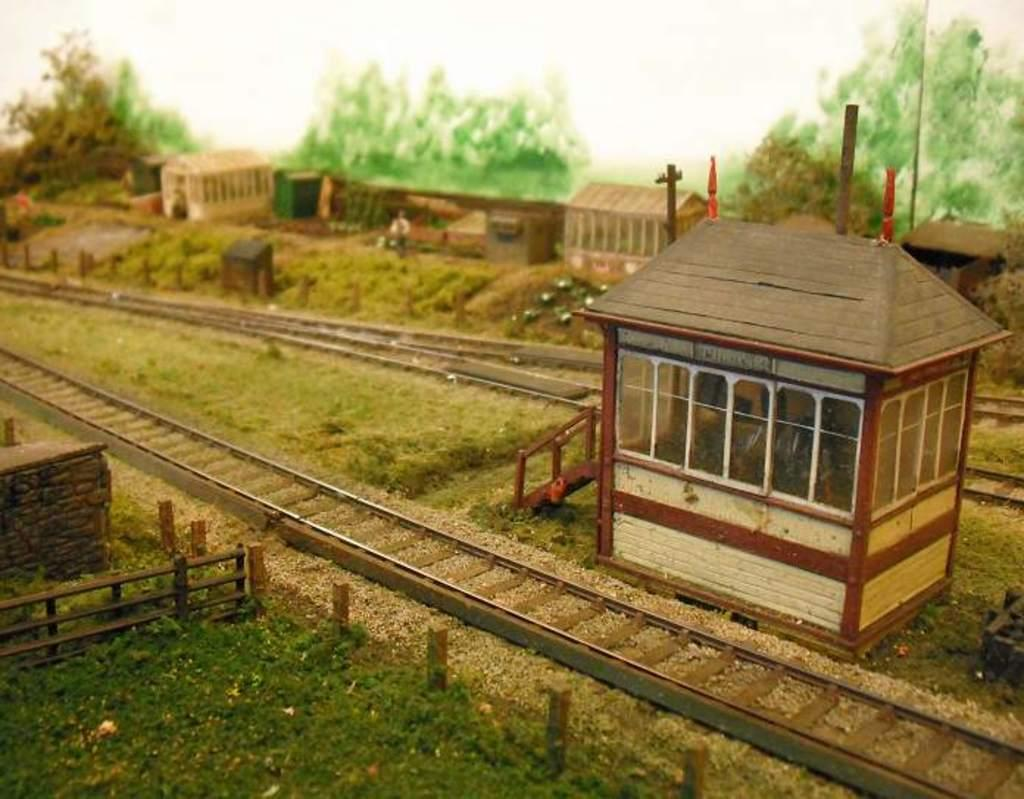What type of structures are visible in the image? There are shelters in the image. What else can be seen in the image besides the shelters? There are poles, trees, grass, a railing, tracks, and objects visible in the image. What type of vegetation is present in the image? There are trees and grass in the image. What might be used for separating or enclosing areas in the image? The railing in the image might be used for separating or enclosing areas. What is the grandmother thinking about while sitting on the front porch in the image? There is no grandmother or front porch present in the image. 